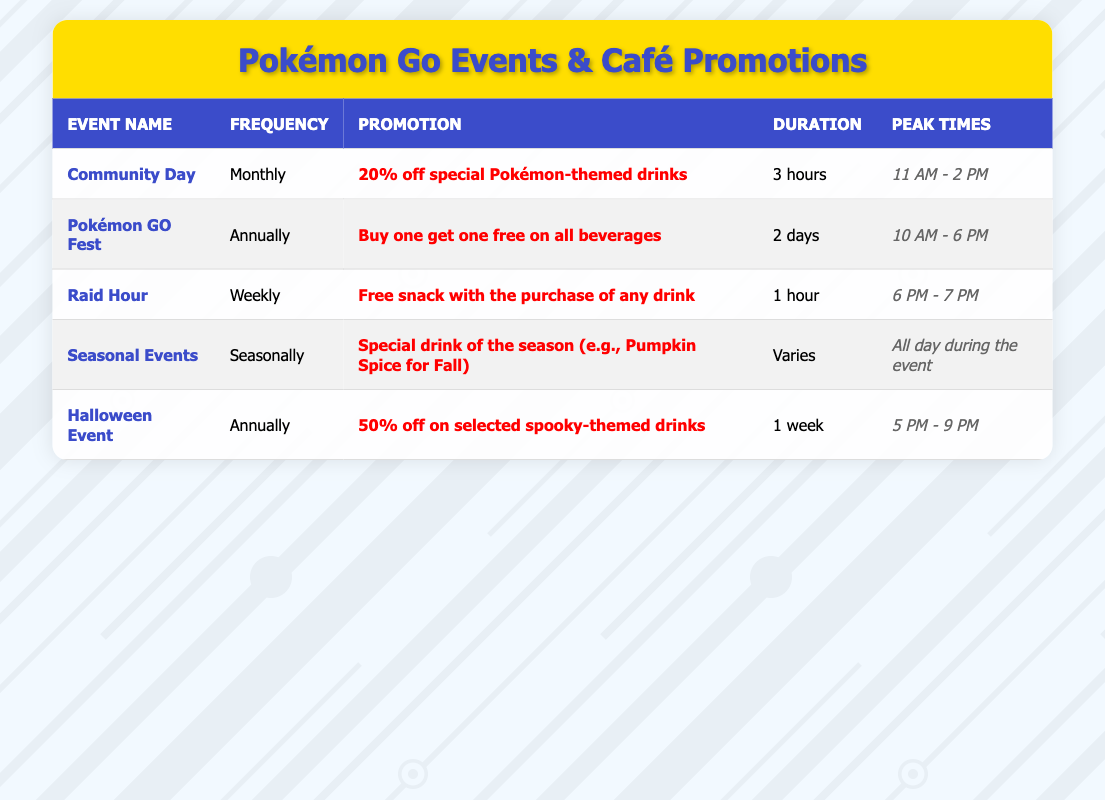What is the promotion for the Community Day event? The promotion for the Community Day event is "20% off special Pokémon-themed drinks." This information can be retrieved directly from the table under the promotion column for the Community Day row.
Answer: 20% off special Pokémon-themed drinks How often does the Pokémon GO Fest occur? The Pokémon GO Fest occurs Annually. This can be found in the event_frequency column specifically for the Pokémon GO Fest row.
Answer: Annually Is there a promotion for the Raid Hour event? Yes, there is a promotion for the Raid Hour event, which is "Free snack with the purchase of any drink." This fact can be validated by checking the promotion section for the Raid Hour in the table.
Answer: Yes What is the duration of the Halloween event? The duration of the Halloween event is 1 week. This information can be found in the duration column for the Halloween Event row.
Answer: 1 week How many events have promotions that include a discount on drinks? There are three events that have promotions which include a discount on drinks: Community Day (20% off), Pokémon GO Fest (Buy one get one free), and Halloween Event (50% off). This requires checking the promotion column for each event to see which ones involve discounts.
Answer: 3 What are the peak times for the Seasonal Events? The peak times for Seasonal Events are "All day during the event." This specific time frame can be found in the peak times column for the Seasonal Events row.
Answer: All day during the event Which event has the longest duration? The Pokémon GO Fest has the longest duration, which is 2 days. To find this, we compare the duration of all events listed in the table, noting that 2 days is longer than other listed durations.
Answer: 2 days Do more events occur weekly than annually? No, there are more events that occur annually (2 events) than weekly (1 event). This requires counting the rows under event_frequency and comparing the totals for weekly and annually events.
Answer: No During which event is the free snack promotion available? The free snack promotion is available during the Raid Hour event, as indicated in the promotion column corresponding to the Raid Hour row.
Answer: Raid Hour 